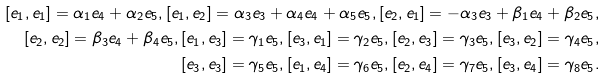Convert formula to latex. <formula><loc_0><loc_0><loc_500><loc_500>[ e _ { 1 } , e _ { 1 } ] = \alpha _ { 1 } e _ { 4 } + \alpha _ { 2 } e _ { 5 } , [ e _ { 1 } , e _ { 2 } ] = \alpha _ { 3 } e _ { 3 } + \alpha _ { 4 } e _ { 4 } + \alpha _ { 5 } e _ { 5 } , [ e _ { 2 } , e _ { 1 } ] = - \alpha _ { 3 } e _ { 3 } + \beta _ { 1 } e _ { 4 } + \beta _ { 2 } e _ { 5 } , \\ [ e _ { 2 } , e _ { 2 } ] = \beta _ { 3 } e _ { 4 } + \beta _ { 4 } e _ { 5 } , [ e _ { 1 } , e _ { 3 } ] = \gamma _ { 1 } e _ { 5 } , [ e _ { 3 } , e _ { 1 } ] = \gamma _ { 2 } e _ { 5 } , [ e _ { 2 } , e _ { 3 } ] = \gamma _ { 3 } e _ { 5 } , [ e _ { 3 } , e _ { 2 } ] = \gamma _ { 4 } e _ { 5 } , \\ [ e _ { 3 } , e _ { 3 } ] = \gamma _ { 5 } e _ { 5 } , [ e _ { 1 } , e _ { 4 } ] = \gamma _ { 6 } e _ { 5 } , [ e _ { 2 } , e _ { 4 } ] = \gamma _ { 7 } e _ { 5 } , [ e _ { 3 } , e _ { 4 } ] = \gamma _ { 8 } e _ { 5 } .</formula> 